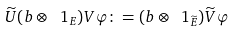Convert formula to latex. <formula><loc_0><loc_0><loc_500><loc_500>\widetilde { U } ( b \otimes \ 1 _ { E } ) V \varphi \colon = ( b \otimes \ 1 _ { \widetilde { E } } ) \widetilde { V } \varphi</formula> 